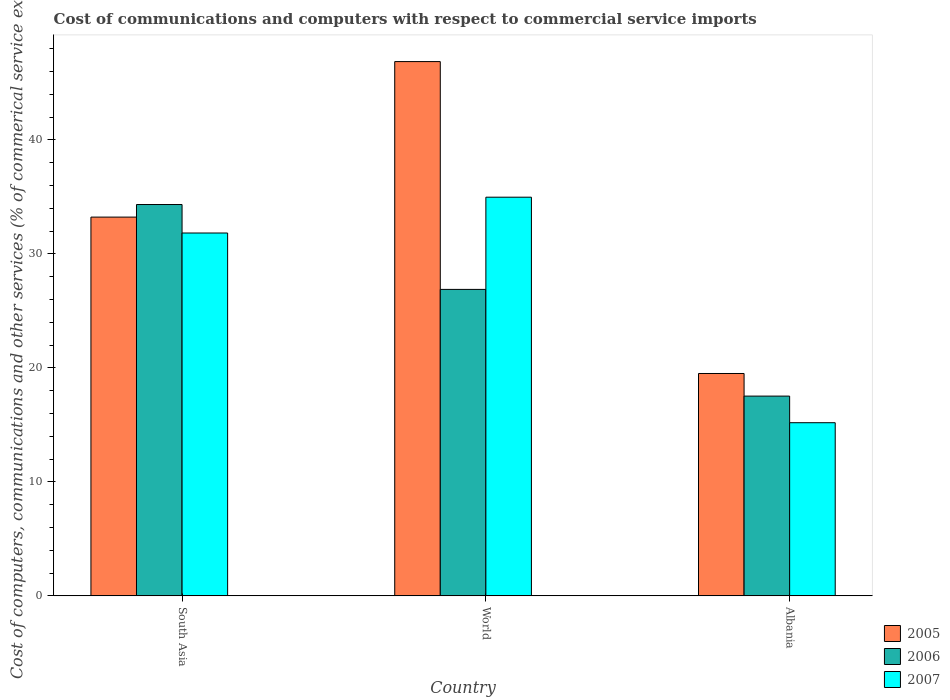How many different coloured bars are there?
Your answer should be compact. 3. How many groups of bars are there?
Provide a short and direct response. 3. Are the number of bars per tick equal to the number of legend labels?
Give a very brief answer. Yes. How many bars are there on the 3rd tick from the right?
Keep it short and to the point. 3. What is the label of the 3rd group of bars from the left?
Your answer should be compact. Albania. In how many cases, is the number of bars for a given country not equal to the number of legend labels?
Your answer should be very brief. 0. What is the cost of communications and computers in 2006 in World?
Your response must be concise. 26.88. Across all countries, what is the maximum cost of communications and computers in 2006?
Give a very brief answer. 34.33. Across all countries, what is the minimum cost of communications and computers in 2007?
Give a very brief answer. 15.19. In which country was the cost of communications and computers in 2007 maximum?
Make the answer very short. World. In which country was the cost of communications and computers in 2007 minimum?
Ensure brevity in your answer.  Albania. What is the total cost of communications and computers in 2007 in the graph?
Your response must be concise. 81.98. What is the difference between the cost of communications and computers in 2006 in South Asia and that in World?
Your response must be concise. 7.45. What is the difference between the cost of communications and computers in 2006 in South Asia and the cost of communications and computers in 2005 in Albania?
Ensure brevity in your answer.  14.82. What is the average cost of communications and computers in 2007 per country?
Your answer should be very brief. 27.33. What is the difference between the cost of communications and computers of/in 2006 and cost of communications and computers of/in 2005 in South Asia?
Your answer should be compact. 1.1. What is the ratio of the cost of communications and computers in 2005 in Albania to that in World?
Your answer should be compact. 0.42. Is the cost of communications and computers in 2007 in Albania less than that in South Asia?
Your response must be concise. Yes. What is the difference between the highest and the second highest cost of communications and computers in 2006?
Keep it short and to the point. -16.81. What is the difference between the highest and the lowest cost of communications and computers in 2006?
Offer a very short reply. 16.81. What does the 2nd bar from the right in World represents?
Provide a short and direct response. 2006. How many bars are there?
Offer a very short reply. 9. How many countries are there in the graph?
Your answer should be compact. 3. What is the difference between two consecutive major ticks on the Y-axis?
Your answer should be very brief. 10. Where does the legend appear in the graph?
Your answer should be compact. Bottom right. What is the title of the graph?
Your response must be concise. Cost of communications and computers with respect to commercial service imports. What is the label or title of the Y-axis?
Your answer should be compact. Cost of computers, communications and other services (% of commerical service exports). What is the Cost of computers, communications and other services (% of commerical service exports) in 2005 in South Asia?
Provide a succinct answer. 33.22. What is the Cost of computers, communications and other services (% of commerical service exports) of 2006 in South Asia?
Offer a very short reply. 34.33. What is the Cost of computers, communications and other services (% of commerical service exports) in 2007 in South Asia?
Your answer should be very brief. 31.83. What is the Cost of computers, communications and other services (% of commerical service exports) of 2005 in World?
Your answer should be very brief. 46.86. What is the Cost of computers, communications and other services (% of commerical service exports) of 2006 in World?
Your response must be concise. 26.88. What is the Cost of computers, communications and other services (% of commerical service exports) in 2007 in World?
Provide a short and direct response. 34.97. What is the Cost of computers, communications and other services (% of commerical service exports) of 2005 in Albania?
Make the answer very short. 19.5. What is the Cost of computers, communications and other services (% of commerical service exports) of 2006 in Albania?
Your answer should be compact. 17.52. What is the Cost of computers, communications and other services (% of commerical service exports) of 2007 in Albania?
Your answer should be very brief. 15.19. Across all countries, what is the maximum Cost of computers, communications and other services (% of commerical service exports) of 2005?
Ensure brevity in your answer.  46.86. Across all countries, what is the maximum Cost of computers, communications and other services (% of commerical service exports) of 2006?
Provide a short and direct response. 34.33. Across all countries, what is the maximum Cost of computers, communications and other services (% of commerical service exports) in 2007?
Give a very brief answer. 34.97. Across all countries, what is the minimum Cost of computers, communications and other services (% of commerical service exports) in 2005?
Make the answer very short. 19.5. Across all countries, what is the minimum Cost of computers, communications and other services (% of commerical service exports) of 2006?
Offer a terse response. 17.52. Across all countries, what is the minimum Cost of computers, communications and other services (% of commerical service exports) of 2007?
Ensure brevity in your answer.  15.19. What is the total Cost of computers, communications and other services (% of commerical service exports) of 2005 in the graph?
Provide a succinct answer. 99.59. What is the total Cost of computers, communications and other services (% of commerical service exports) in 2006 in the graph?
Ensure brevity in your answer.  78.73. What is the total Cost of computers, communications and other services (% of commerical service exports) of 2007 in the graph?
Offer a very short reply. 81.98. What is the difference between the Cost of computers, communications and other services (% of commerical service exports) of 2005 in South Asia and that in World?
Give a very brief answer. -13.64. What is the difference between the Cost of computers, communications and other services (% of commerical service exports) in 2006 in South Asia and that in World?
Ensure brevity in your answer.  7.45. What is the difference between the Cost of computers, communications and other services (% of commerical service exports) of 2007 in South Asia and that in World?
Make the answer very short. -3.14. What is the difference between the Cost of computers, communications and other services (% of commerical service exports) of 2005 in South Asia and that in Albania?
Keep it short and to the point. 13.72. What is the difference between the Cost of computers, communications and other services (% of commerical service exports) of 2006 in South Asia and that in Albania?
Provide a short and direct response. 16.81. What is the difference between the Cost of computers, communications and other services (% of commerical service exports) of 2007 in South Asia and that in Albania?
Make the answer very short. 16.64. What is the difference between the Cost of computers, communications and other services (% of commerical service exports) in 2005 in World and that in Albania?
Your answer should be compact. 27.36. What is the difference between the Cost of computers, communications and other services (% of commerical service exports) of 2006 in World and that in Albania?
Keep it short and to the point. 9.36. What is the difference between the Cost of computers, communications and other services (% of commerical service exports) of 2007 in World and that in Albania?
Keep it short and to the point. 19.78. What is the difference between the Cost of computers, communications and other services (% of commerical service exports) of 2005 in South Asia and the Cost of computers, communications and other services (% of commerical service exports) of 2006 in World?
Your response must be concise. 6.34. What is the difference between the Cost of computers, communications and other services (% of commerical service exports) of 2005 in South Asia and the Cost of computers, communications and other services (% of commerical service exports) of 2007 in World?
Provide a short and direct response. -1.75. What is the difference between the Cost of computers, communications and other services (% of commerical service exports) of 2006 in South Asia and the Cost of computers, communications and other services (% of commerical service exports) of 2007 in World?
Make the answer very short. -0.64. What is the difference between the Cost of computers, communications and other services (% of commerical service exports) of 2005 in South Asia and the Cost of computers, communications and other services (% of commerical service exports) of 2006 in Albania?
Your response must be concise. 15.7. What is the difference between the Cost of computers, communications and other services (% of commerical service exports) of 2005 in South Asia and the Cost of computers, communications and other services (% of commerical service exports) of 2007 in Albania?
Offer a very short reply. 18.03. What is the difference between the Cost of computers, communications and other services (% of commerical service exports) of 2006 in South Asia and the Cost of computers, communications and other services (% of commerical service exports) of 2007 in Albania?
Ensure brevity in your answer.  19.14. What is the difference between the Cost of computers, communications and other services (% of commerical service exports) in 2005 in World and the Cost of computers, communications and other services (% of commerical service exports) in 2006 in Albania?
Provide a short and direct response. 29.34. What is the difference between the Cost of computers, communications and other services (% of commerical service exports) of 2005 in World and the Cost of computers, communications and other services (% of commerical service exports) of 2007 in Albania?
Your answer should be very brief. 31.68. What is the difference between the Cost of computers, communications and other services (% of commerical service exports) in 2006 in World and the Cost of computers, communications and other services (% of commerical service exports) in 2007 in Albania?
Your response must be concise. 11.69. What is the average Cost of computers, communications and other services (% of commerical service exports) in 2005 per country?
Provide a short and direct response. 33.2. What is the average Cost of computers, communications and other services (% of commerical service exports) in 2006 per country?
Ensure brevity in your answer.  26.24. What is the average Cost of computers, communications and other services (% of commerical service exports) of 2007 per country?
Offer a very short reply. 27.33. What is the difference between the Cost of computers, communications and other services (% of commerical service exports) of 2005 and Cost of computers, communications and other services (% of commerical service exports) of 2006 in South Asia?
Give a very brief answer. -1.1. What is the difference between the Cost of computers, communications and other services (% of commerical service exports) in 2005 and Cost of computers, communications and other services (% of commerical service exports) in 2007 in South Asia?
Give a very brief answer. 1.39. What is the difference between the Cost of computers, communications and other services (% of commerical service exports) of 2006 and Cost of computers, communications and other services (% of commerical service exports) of 2007 in South Asia?
Offer a terse response. 2.5. What is the difference between the Cost of computers, communications and other services (% of commerical service exports) of 2005 and Cost of computers, communications and other services (% of commerical service exports) of 2006 in World?
Keep it short and to the point. 19.98. What is the difference between the Cost of computers, communications and other services (% of commerical service exports) in 2005 and Cost of computers, communications and other services (% of commerical service exports) in 2007 in World?
Provide a succinct answer. 11.89. What is the difference between the Cost of computers, communications and other services (% of commerical service exports) of 2006 and Cost of computers, communications and other services (% of commerical service exports) of 2007 in World?
Ensure brevity in your answer.  -8.09. What is the difference between the Cost of computers, communications and other services (% of commerical service exports) of 2005 and Cost of computers, communications and other services (% of commerical service exports) of 2006 in Albania?
Ensure brevity in your answer.  1.98. What is the difference between the Cost of computers, communications and other services (% of commerical service exports) of 2005 and Cost of computers, communications and other services (% of commerical service exports) of 2007 in Albania?
Provide a succinct answer. 4.32. What is the difference between the Cost of computers, communications and other services (% of commerical service exports) in 2006 and Cost of computers, communications and other services (% of commerical service exports) in 2007 in Albania?
Make the answer very short. 2.33. What is the ratio of the Cost of computers, communications and other services (% of commerical service exports) of 2005 in South Asia to that in World?
Your answer should be compact. 0.71. What is the ratio of the Cost of computers, communications and other services (% of commerical service exports) of 2006 in South Asia to that in World?
Your answer should be compact. 1.28. What is the ratio of the Cost of computers, communications and other services (% of commerical service exports) of 2007 in South Asia to that in World?
Make the answer very short. 0.91. What is the ratio of the Cost of computers, communications and other services (% of commerical service exports) in 2005 in South Asia to that in Albania?
Your response must be concise. 1.7. What is the ratio of the Cost of computers, communications and other services (% of commerical service exports) of 2006 in South Asia to that in Albania?
Your answer should be very brief. 1.96. What is the ratio of the Cost of computers, communications and other services (% of commerical service exports) of 2007 in South Asia to that in Albania?
Make the answer very short. 2.1. What is the ratio of the Cost of computers, communications and other services (% of commerical service exports) in 2005 in World to that in Albania?
Ensure brevity in your answer.  2.4. What is the ratio of the Cost of computers, communications and other services (% of commerical service exports) of 2006 in World to that in Albania?
Provide a short and direct response. 1.53. What is the ratio of the Cost of computers, communications and other services (% of commerical service exports) in 2007 in World to that in Albania?
Your response must be concise. 2.3. What is the difference between the highest and the second highest Cost of computers, communications and other services (% of commerical service exports) of 2005?
Give a very brief answer. 13.64. What is the difference between the highest and the second highest Cost of computers, communications and other services (% of commerical service exports) of 2006?
Your answer should be compact. 7.45. What is the difference between the highest and the second highest Cost of computers, communications and other services (% of commerical service exports) in 2007?
Provide a short and direct response. 3.14. What is the difference between the highest and the lowest Cost of computers, communications and other services (% of commerical service exports) in 2005?
Offer a terse response. 27.36. What is the difference between the highest and the lowest Cost of computers, communications and other services (% of commerical service exports) in 2006?
Provide a succinct answer. 16.81. What is the difference between the highest and the lowest Cost of computers, communications and other services (% of commerical service exports) in 2007?
Keep it short and to the point. 19.78. 